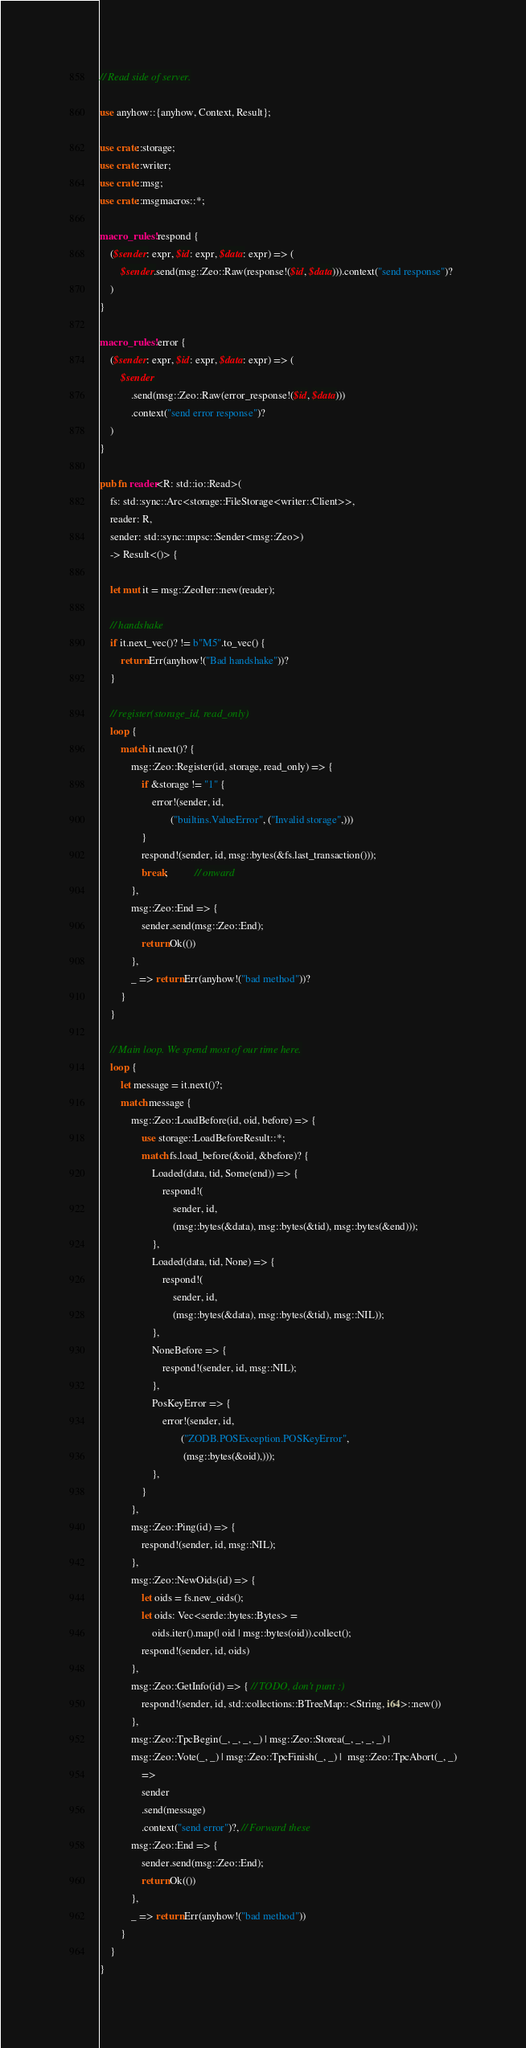Convert code to text. <code><loc_0><loc_0><loc_500><loc_500><_Rust_>// Read side of server.

use anyhow::{anyhow, Context, Result};

use crate::storage;
use crate::writer;
use crate::msg;
use crate::msgmacros::*;

macro_rules! respond {
    ($sender: expr, $id: expr, $data: expr) => (
        $sender.send(msg::Zeo::Raw(response!($id, $data))).context("send response")?
    )
}

macro_rules! error {
    ($sender: expr, $id: expr, $data: expr) => (
        $sender
            .send(msg::Zeo::Raw(error_response!($id, $data)))
            .context("send error response")?
    )
}

pub fn reader<R: std::io::Read>(
    fs: std::sync::Arc<storage::FileStorage<writer::Client>>,
    reader: R,
    sender: std::sync::mpsc::Sender<msg::Zeo>)
    -> Result<()> {

    let mut it = msg::ZeoIter::new(reader);

    // handshake
    if it.next_vec()? != b"M5".to_vec() {
        return Err(anyhow!("Bad handshake"))?
    }

    // register(storage_id, read_only)
    loop {
        match it.next()? {
            msg::Zeo::Register(id, storage, read_only) => {
                if &storage != "1" {
                    error!(sender, id,
                           ("builtins.ValueError", ("Invalid storage",)))
                }
                respond!(sender, id, msg::bytes(&fs.last_transaction()));
                break;          // onward
            },
            msg::Zeo::End => {
                sender.send(msg::Zeo::End);
                return Ok(())
            },
            _ => return Err(anyhow!("bad method"))?
        }
    }

    // Main loop. We spend most of our time here.
    loop {
        let message = it.next()?;
        match message {
            msg::Zeo::LoadBefore(id, oid, before) => {
                use storage::LoadBeforeResult::*;
                match fs.load_before(&oid, &before)? {
                    Loaded(data, tid, Some(end)) => {
                        respond!(
                            sender, id,
                            (msg::bytes(&data), msg::bytes(&tid), msg::bytes(&end)));
                    },
                    Loaded(data, tid, None) => {
                        respond!(
                            sender, id,
                            (msg::bytes(&data), msg::bytes(&tid), msg::NIL));
                    },
                    NoneBefore => {
                        respond!(sender, id, msg::NIL);
                    },
                    PosKeyError => {
                        error!(sender, id,
                               ("ZODB.POSException.POSKeyError",
                                (msg::bytes(&oid),)));
                    },
                }
            },
            msg::Zeo::Ping(id) => {
                respond!(sender, id, msg::NIL);
            },
            msg::Zeo::NewOids(id) => {
                let oids = fs.new_oids();
                let oids: Vec<serde::bytes::Bytes> =
                    oids.iter().map(| oid | msg::bytes(oid)).collect();
                respond!(sender, id, oids)
            },
            msg::Zeo::GetInfo(id) => { // TODO, don't punt :)
                respond!(sender, id, std::collections::BTreeMap::<String, i64>::new())
            },
            msg::Zeo::TpcBegin(_, _, _, _) | msg::Zeo::Storea(_, _, _, _) |
            msg::Zeo::Vote(_, _) | msg::Zeo::TpcFinish(_, _) |  msg::Zeo::TpcAbort(_, _)
                =>
                sender
                .send(message)
                .context("send error")?, // Forward these
            msg::Zeo::End => {
                sender.send(msg::Zeo::End);
                return Ok(())
            },
            _ => return Err(anyhow!("bad method"))
        }            
    }
}
</code> 